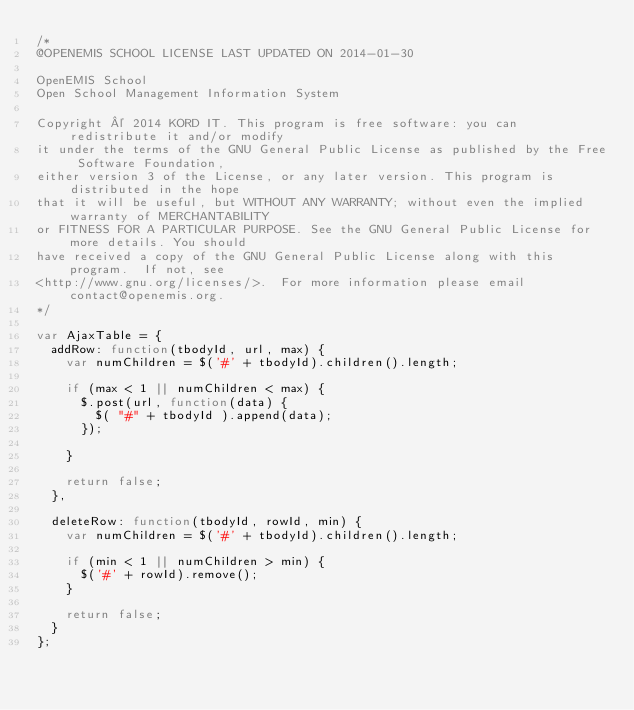<code> <loc_0><loc_0><loc_500><loc_500><_JavaScript_>/*
@OPENEMIS SCHOOL LICENSE LAST UPDATED ON 2014-01-30

OpenEMIS School
Open School Management Information System

Copyright © 2014 KORD IT. This program is free software: you can redistribute it and/or modify 
it under the terms of the GNU General Public License as published by the Free Software Foundation, 
either version 3 of the License, or any later version. This program is distributed in the hope 
that it will be useful, but WITHOUT ANY WARRANTY; without even the implied warranty of MERCHANTABILITY
or FITNESS FOR A PARTICULAR PURPOSE. See the GNU General Public License for more details. You should 
have received a copy of the GNU General Public License along with this program.  If not, see 
<http://www.gnu.org/licenses/>.  For more information please email contact@openemis.org.
*/

var AjaxTable = {
	addRow: function(tbodyId, url, max) {
		var numChildren = $('#' + tbodyId).children().length;
		
		if (max < 1 || numChildren < max) {
			$.post(url, function(data) {
				$( "#" + tbodyId ).append(data);
			});
			
		}
		
		return false;
	},
	
	deleteRow: function(tbodyId, rowId, min) {
		var numChildren = $('#' + tbodyId).children().length;
		
		if (min < 1 || numChildren > min) {
			$('#' + rowId).remove();
		}
		
		return false;
	}
}; 
</code> 